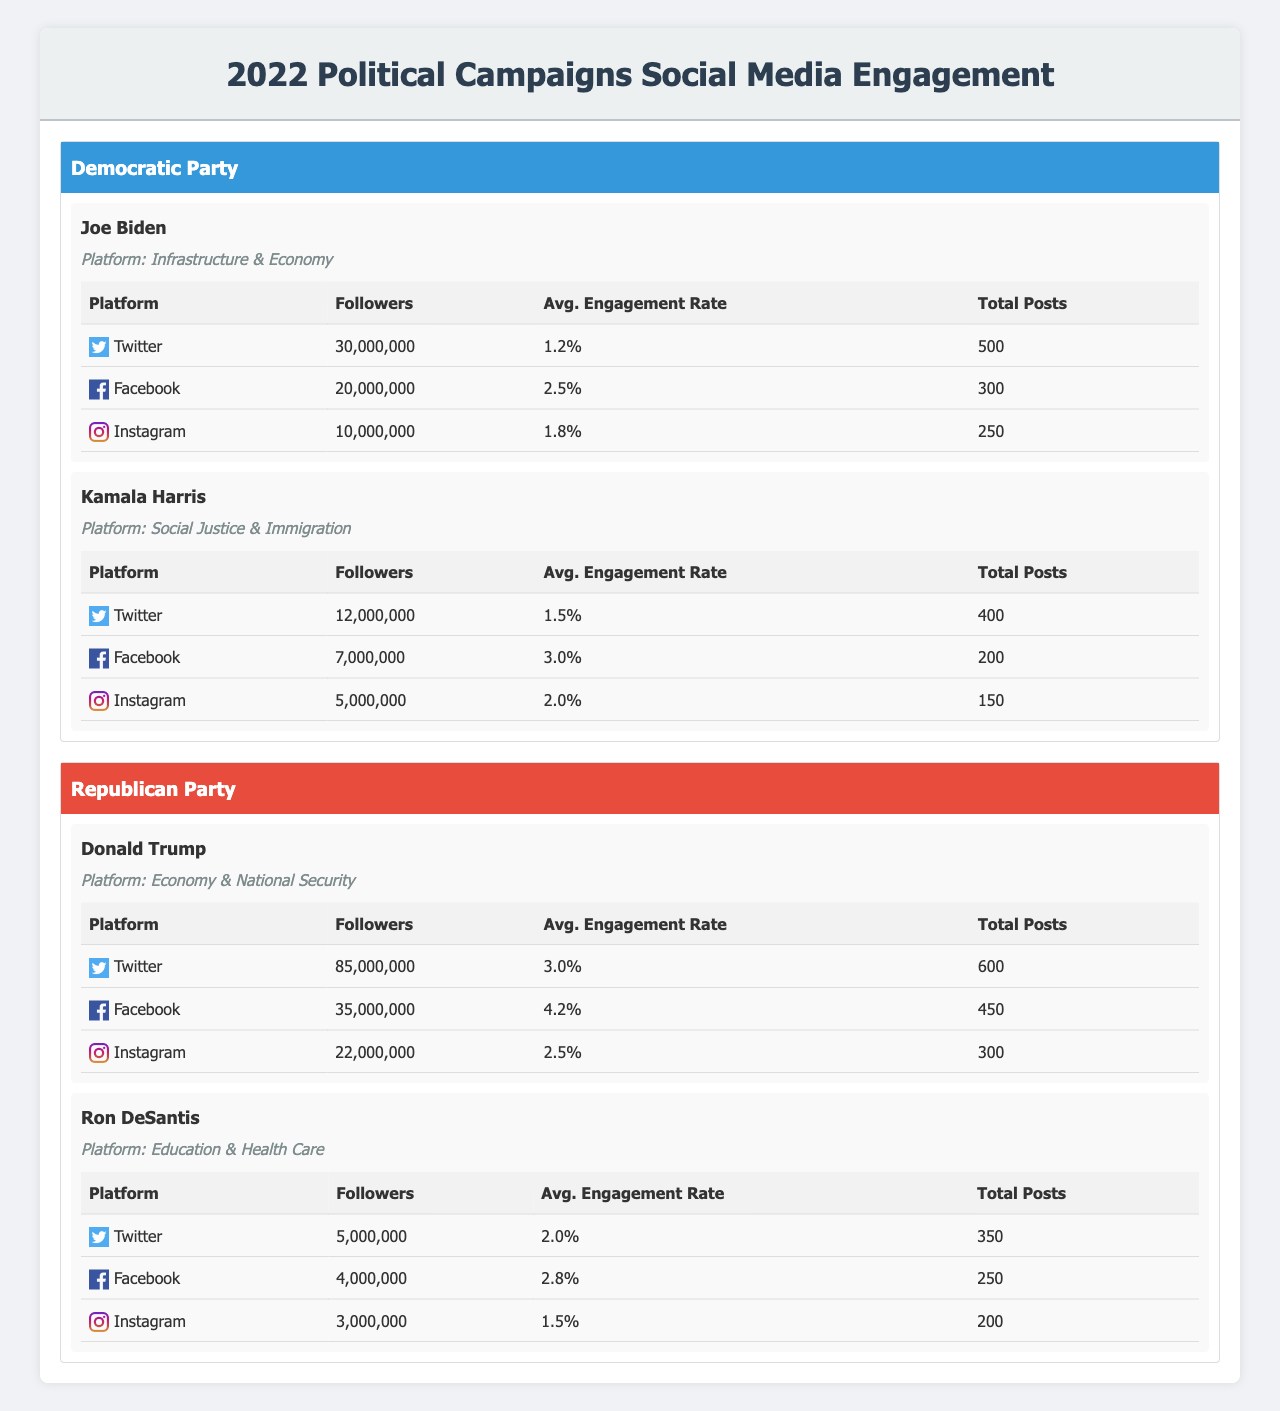What is the average engagement rate for Joe Biden across all platforms? Joe Biden has engagement rates of 1.2% on Twitter, 2.5% on Facebook, and 1.8% on Instagram. To find the average, sum the engagement rates: 1.2 + 2.5 + 1.8 = 5.5. There are three platforms, so divide by 3: 5.5 / 3 = 1.83.
Answer: 1.83% Which candidate has the highest total followers on social media? By looking at the total followers, Donald Trump has 85,000,000 on Twitter, 35,000,000 on Facebook, and 22,000,000 on Instagram; this sums up to 142,000,000. The next highest is Joe Biden with 30,000,000 on Twitter, 20,000,000 on Facebook, and 10,000,000 on Instagram, summing to 60,000,000. Trump has more total followers than any other candidate.
Answer: Donald Trump Is Kamala Harris' average engagement rate higher than Joe Biden's? Joe Biden's average engagement rate is 1.83% as calculated above. Kamala Harris has engagement rates of 1.5% on Twitter, 3.0% on Facebook, and 2.0% on Instagram. Summing these gives 1.5 + 3.0 + 2.0 = 6.5, and dividing by 3 yields an average of 6.5 / 3 = 2.17%. Since 2.17% is higher than 1.83%, Kamala Harris has a higher average engagement rate than Joe Biden.
Answer: Yes How many total posts did Ron DeSantis make on social media? Ron DeSantis has made 350 posts on Twitter, 250 on Facebook, and 200 on Instagram. To find the total, sum these numbers: 350 + 250 + 200 = 800 posts.
Answer: 800 Does Joe Biden have more total Facebook followers than Donald Trump? Joe Biden has 20,000,000 followers on Facebook, while Donald Trump has 35,000,000. Since 20,000,000 is less than 35,000,000, Joe Biden does not have more total Facebook followers than Donald Trump.
Answer: No 